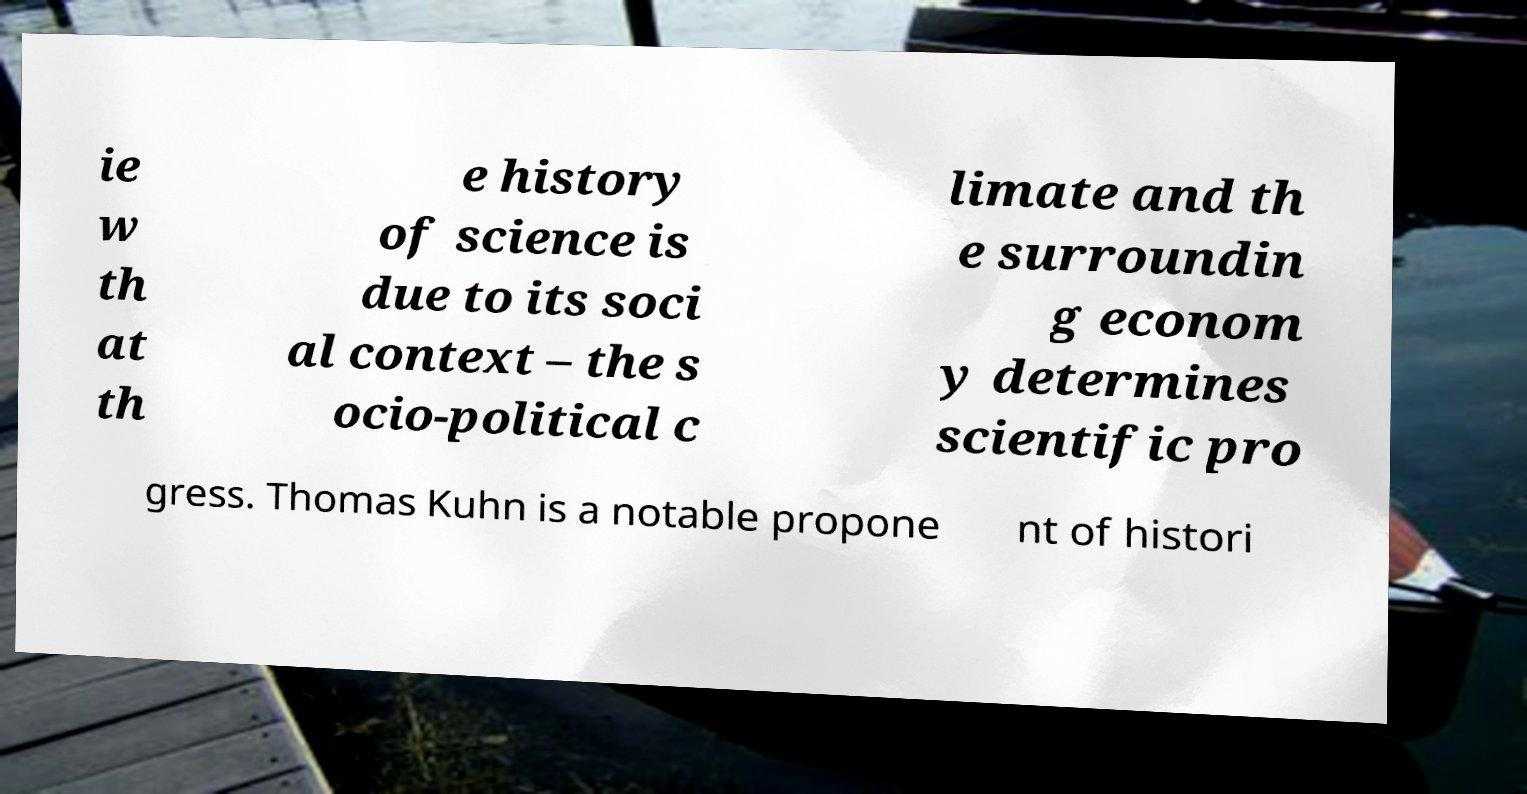Can you accurately transcribe the text from the provided image for me? ie w th at th e history of science is due to its soci al context – the s ocio-political c limate and th e surroundin g econom y determines scientific pro gress. Thomas Kuhn is a notable propone nt of histori 